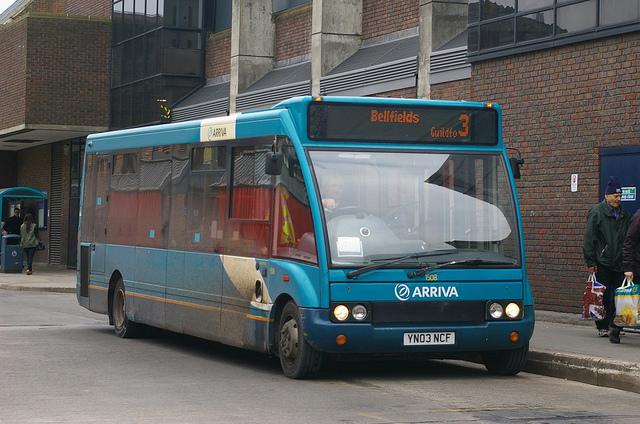What is the name of this tour bus company?
Give a very brief answer. Arriva. Are there trees in the picture?
Concise answer only. No. What color is the bus?
Write a very short answer. Blue. Are there people near the bus?
Write a very short answer. Yes. What is the bus company's name?
Short answer required. Arriva. Is that a brick building?
Short answer required. Yes. 